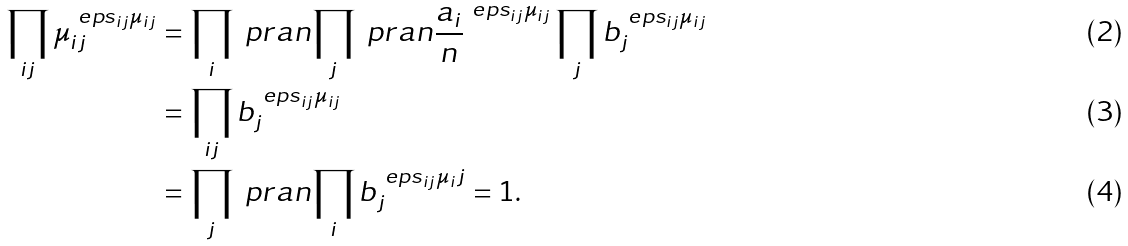<formula> <loc_0><loc_0><loc_500><loc_500>\prod _ { i j } \mu _ { i j } ^ { \ e p s _ { i j } \mu _ { i j } } & = \prod _ { i } \ p r a n { \prod _ { j } \ p r a n { \frac { a _ { i } } { n } } ^ { \ e p s _ { i j } \mu _ { i j } } \prod _ { j } b _ { j } ^ { \ e p s _ { i j } \mu _ { i j } } } \\ & = \prod _ { i j } b _ { j } ^ { \ e p s _ { i j } \mu _ { i j } } \\ & = \prod _ { j } \ p r a n { \prod _ { i } b _ { j } ^ { \ e p s _ { i j } \mu _ { i } j } } = 1 .</formula> 